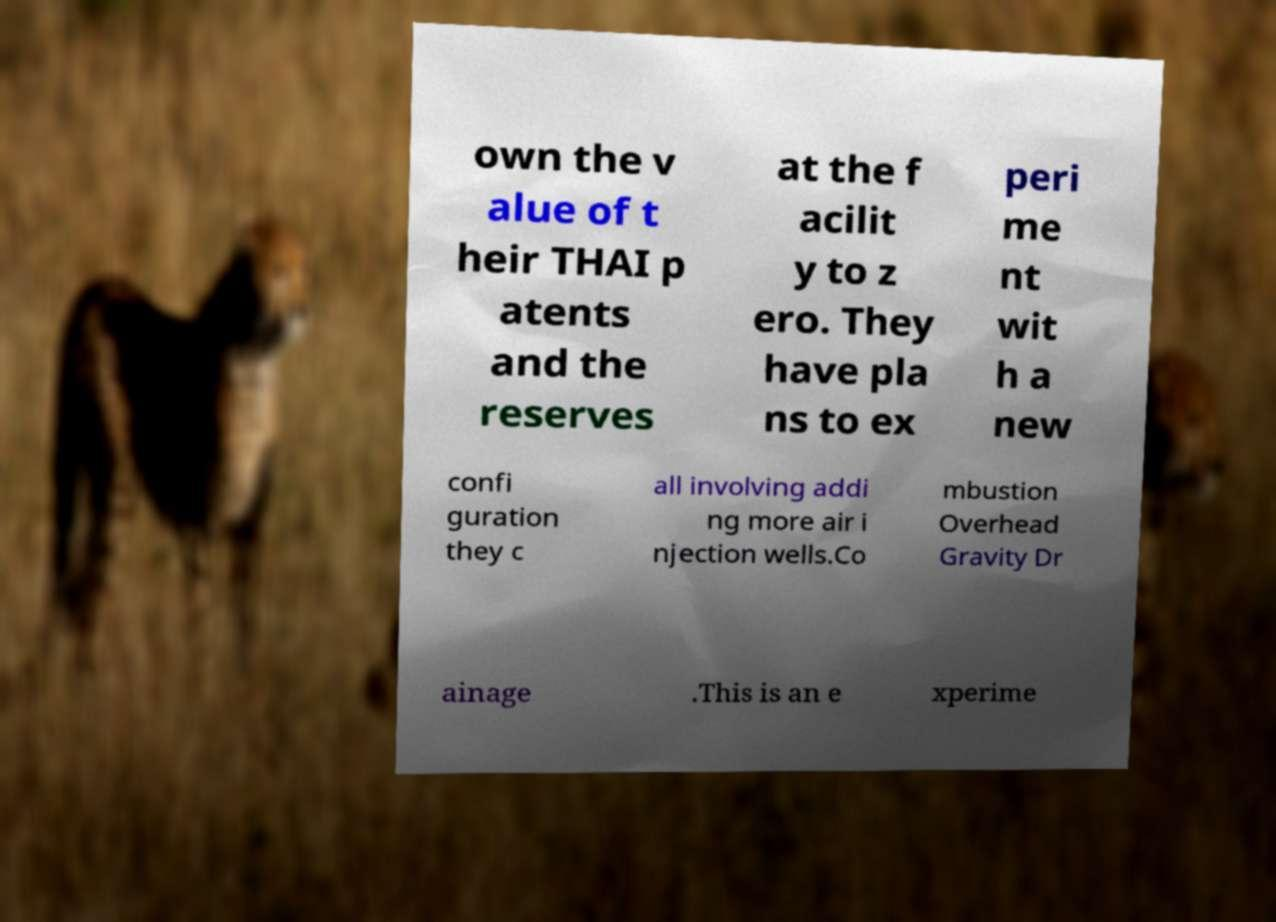There's text embedded in this image that I need extracted. Can you transcribe it verbatim? own the v alue of t heir THAI p atents and the reserves at the f acilit y to z ero. They have pla ns to ex peri me nt wit h a new confi guration they c all involving addi ng more air i njection wells.Co mbustion Overhead Gravity Dr ainage .This is an e xperime 